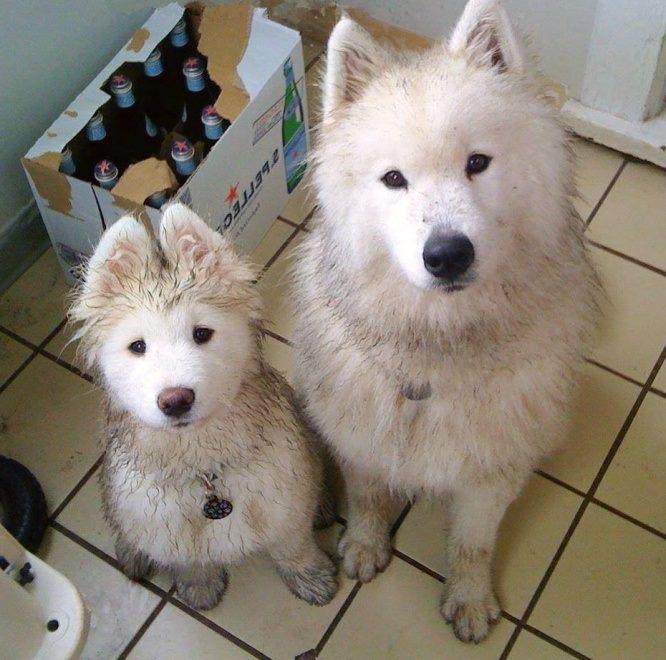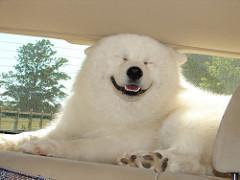The first image is the image on the left, the second image is the image on the right. Evaluate the accuracy of this statement regarding the images: "An image includes a reclining white dog with both eyes shut.". Is it true? Answer yes or no. Yes. The first image is the image on the left, the second image is the image on the right. Evaluate the accuracy of this statement regarding the images: "The dog's tongue is sticking out in at least one of the images.". Is it true? Answer yes or no. No. 